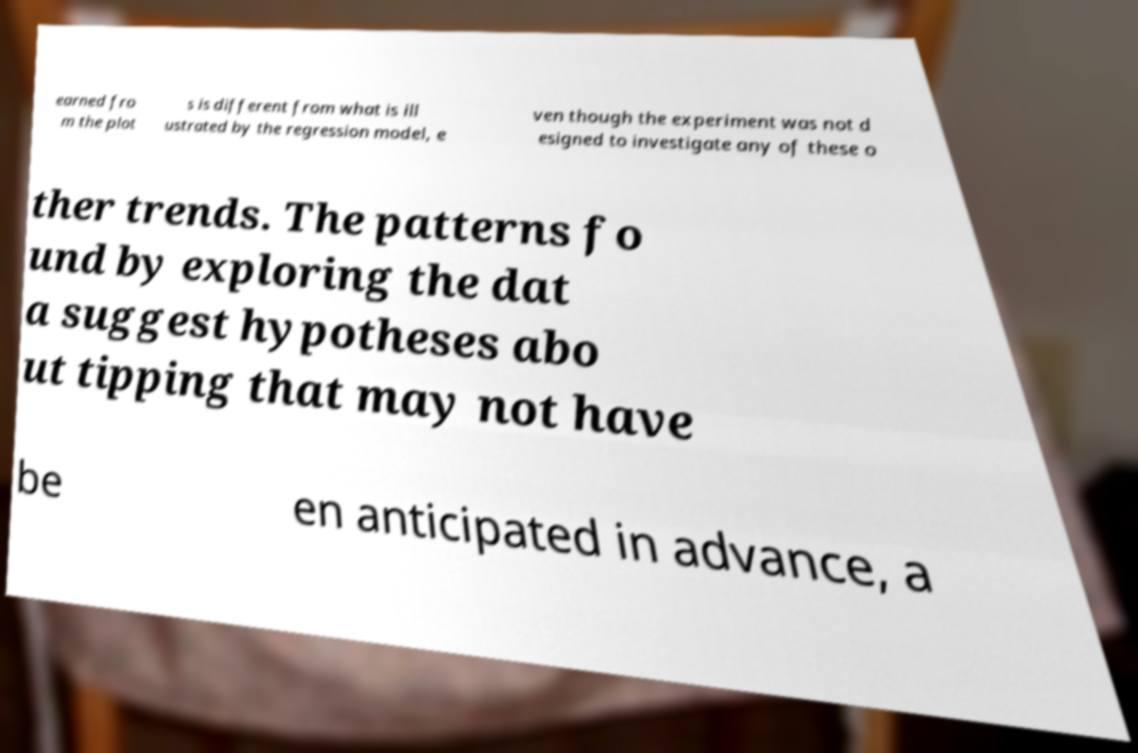I need the written content from this picture converted into text. Can you do that? earned fro m the plot s is different from what is ill ustrated by the regression model, e ven though the experiment was not d esigned to investigate any of these o ther trends. The patterns fo und by exploring the dat a suggest hypotheses abo ut tipping that may not have be en anticipated in advance, a 